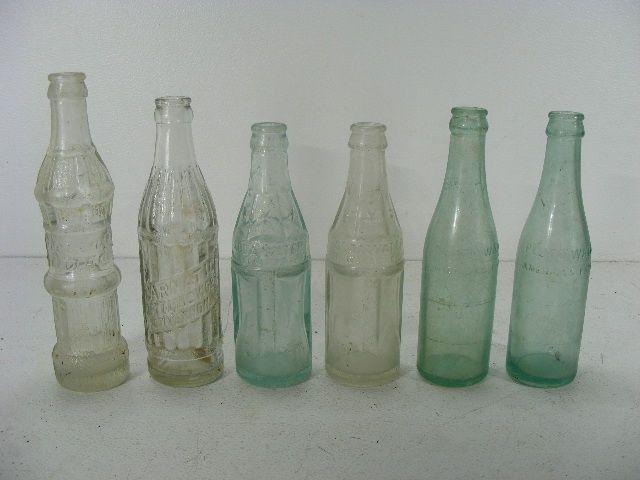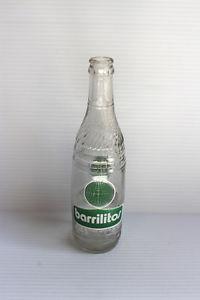The first image is the image on the left, the second image is the image on the right. Examine the images to the left and right. Is the description "The right image contains exactly one glass bottle." accurate? Answer yes or no. Yes. The first image is the image on the left, the second image is the image on the right. Examine the images to the left and right. Is the description "One image shows a single upright, uncapped clear bottle with a colored label and ridges around the glass, and the other image shows at least six varied glass bottles without colored labels." accurate? Answer yes or no. Yes. 